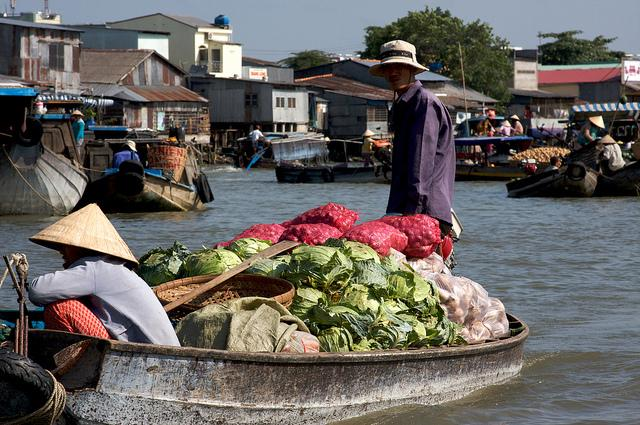What kind of boat is this?

Choices:
A) tow boat
B) fishing
C) transport
D) coast guard transport 